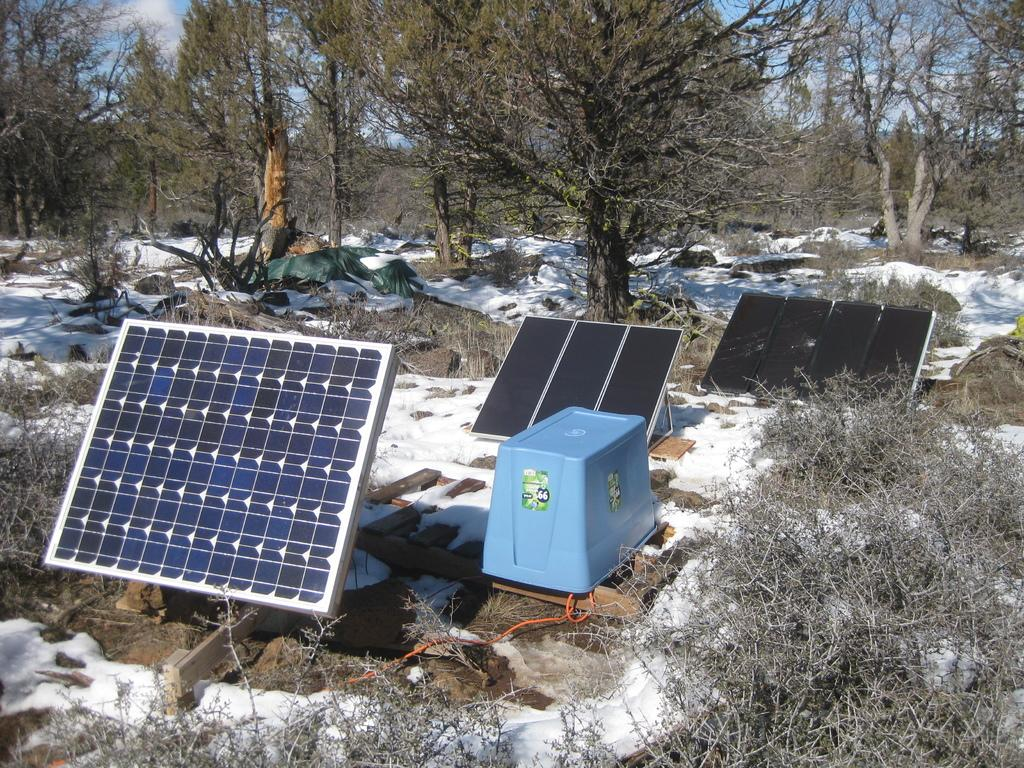What type of energy-generating devices are present in the image? There are solar boards in the image. Where are the solar boards placed in the image? The solar boards are placed on the snow. What natural elements can be seen in the image? There are trees visible in the image. What type of bead is used to decorate the solar boards in the image? There are no beads present on the solar boards in the image. How many beds are visible in the image? There are no beds present in the image. 